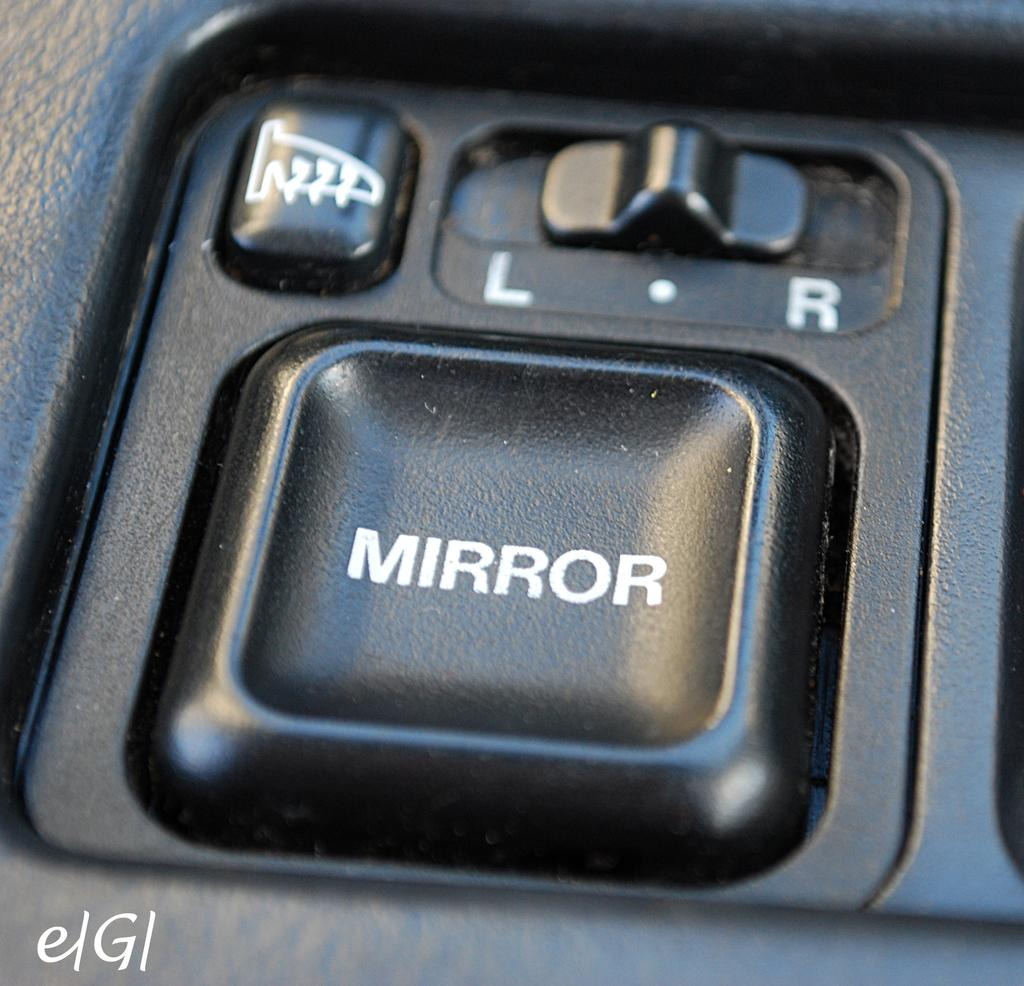What type of objects are present in the image with text on them? There are black buttons with text in the image. Is there any additional information or branding present in the image? Yes, there is a watermark at the bottom of the image. Can you tell me who the owner of the sail is in the image? There is no sail present in the image, so it is not possible to determine the owner. 